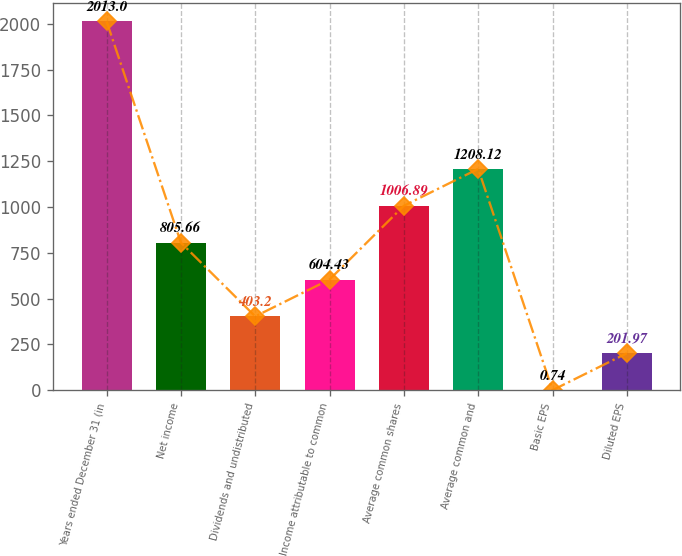<chart> <loc_0><loc_0><loc_500><loc_500><bar_chart><fcel>Years ended December 31 (in<fcel>Net income<fcel>Dividends and undistributed<fcel>Income attributable to common<fcel>Average common shares<fcel>Average common and<fcel>Basic EPS<fcel>Diluted EPS<nl><fcel>2013<fcel>805.66<fcel>403.2<fcel>604.43<fcel>1006.89<fcel>1208.12<fcel>0.74<fcel>201.97<nl></chart> 